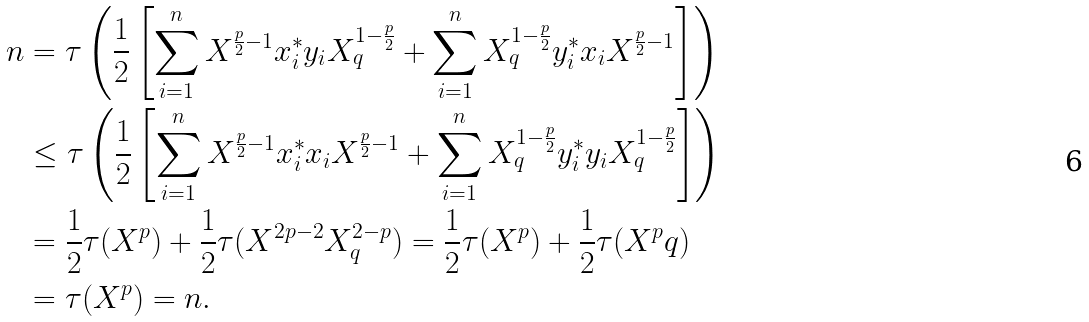<formula> <loc_0><loc_0><loc_500><loc_500>n & = \tau \left ( \frac { 1 } { 2 } \left [ \sum ^ { n } _ { i = 1 } X ^ { \frac { p } { 2 } - 1 } x ^ { * } _ { i } y _ { i } X ^ { 1 - \frac { p } { 2 } } _ { q } + \sum ^ { n } _ { i = 1 } X ^ { 1 - \frac { p } { 2 } } _ { q } y ^ { * } _ { i } x _ { i } X ^ { \frac { p } { 2 } - 1 } \right ] \right ) \\ & \leq \tau \left ( \frac { 1 } { 2 } \left [ \sum ^ { n } _ { i = 1 } X ^ { \frac { p } { 2 } - 1 } x ^ { * } _ { i } x _ { i } X ^ { \frac { p } { 2 } - 1 } + \sum ^ { n } _ { i = 1 } X ^ { 1 - \frac { p } { 2 } } _ { q } y ^ { * } _ { i } y _ { i } X ^ { 1 - \frac { p } { 2 } } _ { q } \right ] \right ) \\ & = \frac { 1 } { 2 } \tau ( X ^ { p } ) + \frac { 1 } { 2 } \tau ( X ^ { 2 p - 2 } X ^ { 2 - p } _ { q } ) = \frac { 1 } { 2 } \tau ( X ^ { p } ) + \frac { 1 } { 2 } \tau ( X ^ { p } q ) \\ & = \tau ( X ^ { p } ) = n .</formula> 